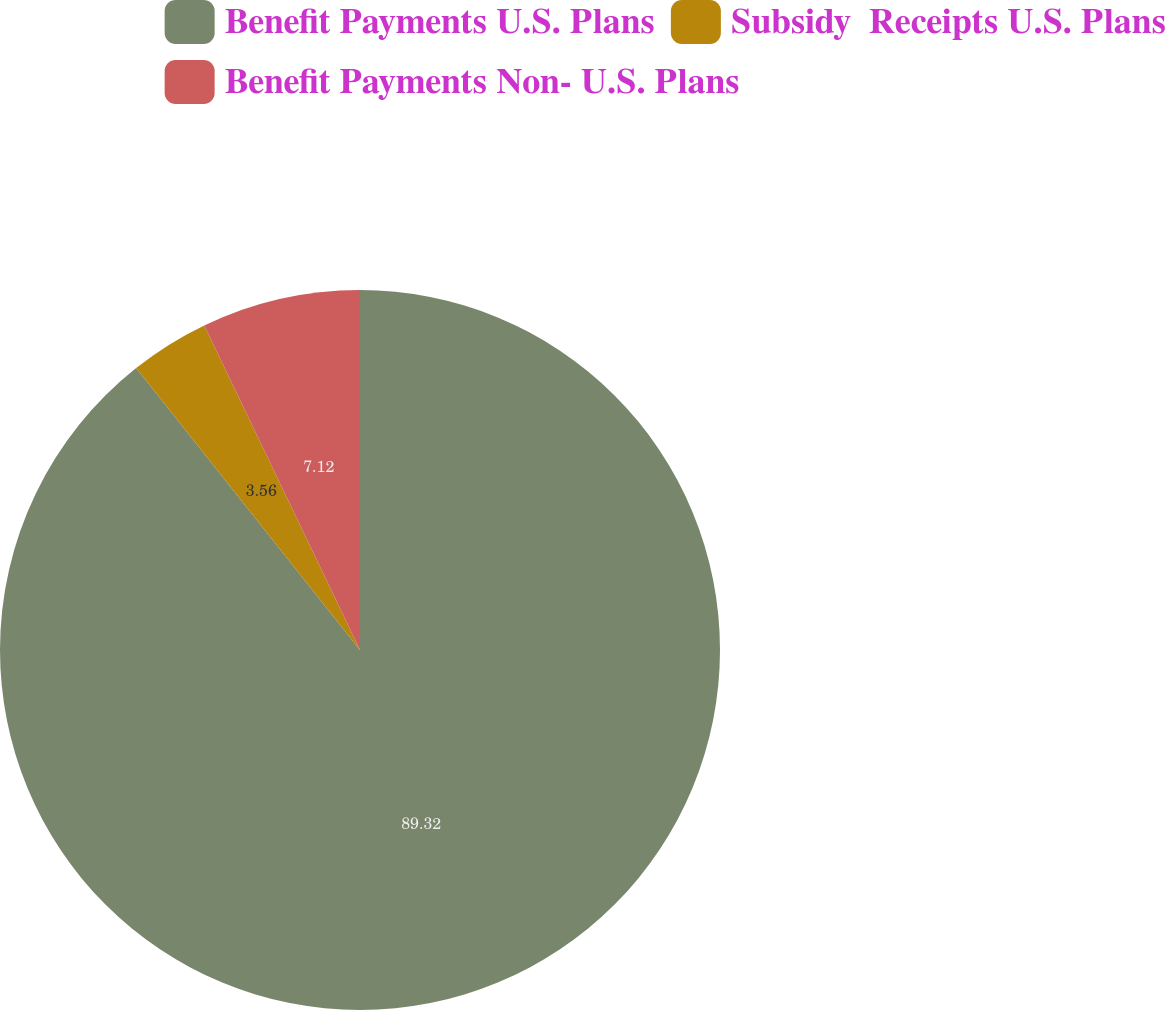<chart> <loc_0><loc_0><loc_500><loc_500><pie_chart><fcel>Benefit Payments U.S. Plans<fcel>Subsidy  Receipts U.S. Plans<fcel>Benefit Payments Non- U.S. Plans<nl><fcel>89.32%<fcel>3.56%<fcel>7.12%<nl></chart> 